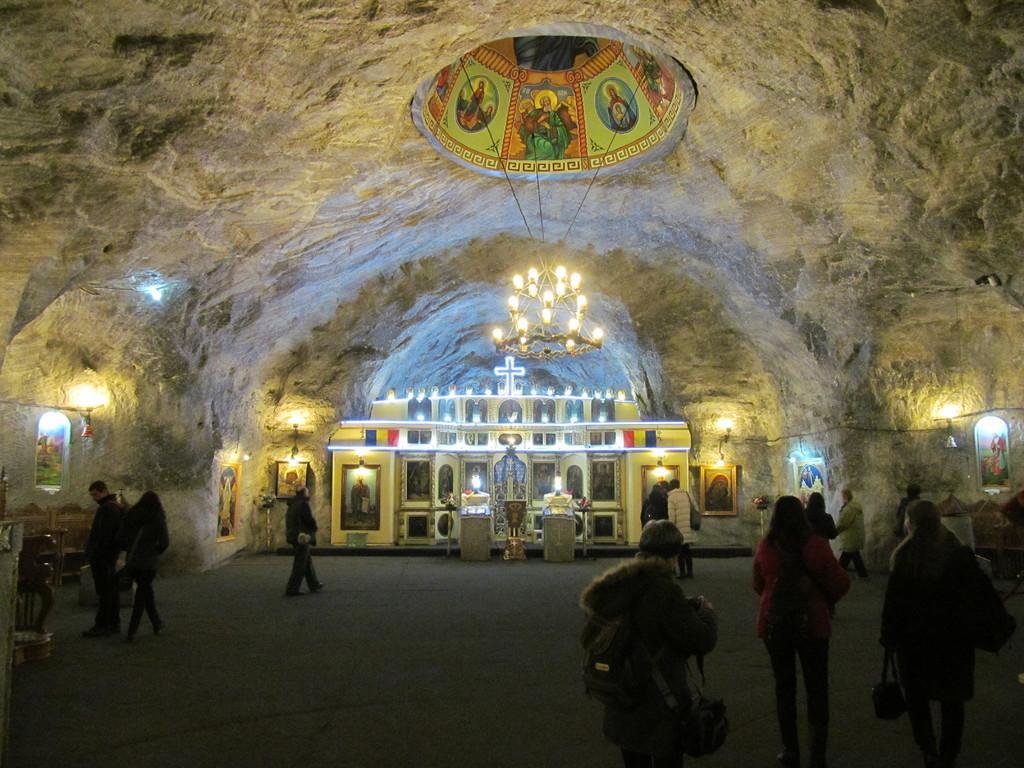Can you describe this image briefly? In this image we can see there are people walking on the ground and holding bags. And we can see the photo frames attached to the wall. And there are lights on the racks, photo frames and few objects inside the cave. At the top we can see there is a board with images. And we can see the chandelier tied to the wall with the help of ropes. 